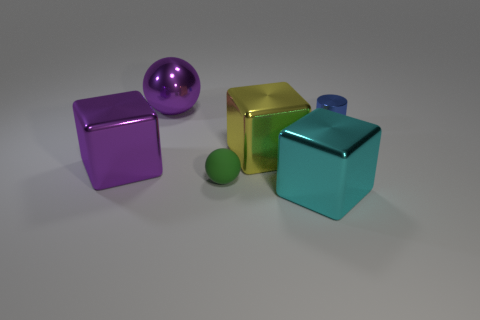How many tiny gray cylinders are there?
Your answer should be compact. 0. Is there a yellow metallic block of the same size as the shiny ball?
Give a very brief answer. Yes. Is the number of blue cylinders that are in front of the big purple block less than the number of small cyan matte things?
Your answer should be compact. No. Is the green ball the same size as the cyan cube?
Provide a short and direct response. No. What is the size of the purple sphere that is the same material as the tiny blue object?
Make the answer very short. Large. What number of other cylinders are the same color as the cylinder?
Offer a terse response. 0. Are there fewer objects right of the cyan metallic cube than blue metallic cylinders that are in front of the large yellow block?
Your response must be concise. No. There is a large purple metal thing that is in front of the yellow thing; is it the same shape as the rubber object?
Provide a short and direct response. No. Are there any other things that are the same material as the green thing?
Give a very brief answer. No. Do the purple object in front of the blue metal cylinder and the yellow object have the same material?
Your answer should be compact. Yes. 